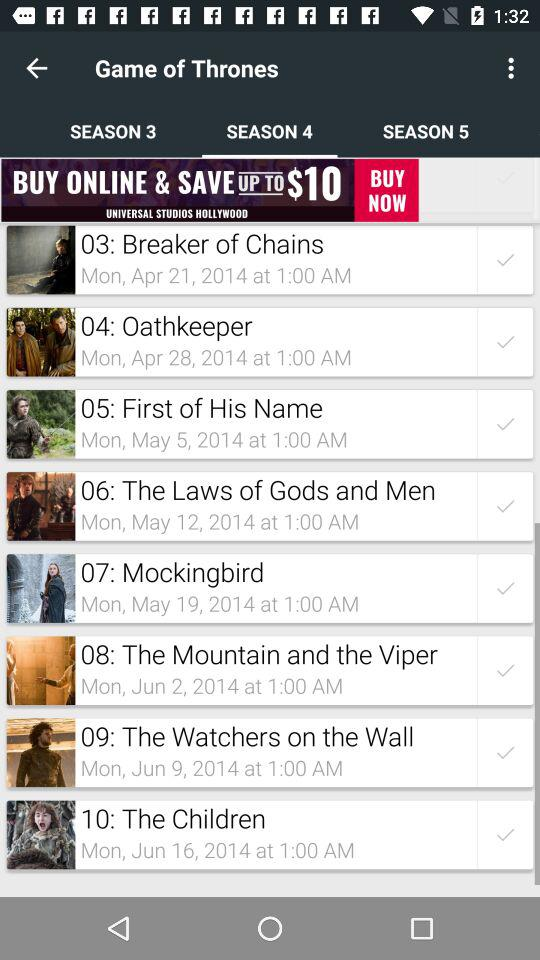What is the date and time for the third episode, "Breaker of Chains"? The date and time for the third episode, "Breaker of Chains" are Monday, April 21, 2014 and 1:00 AM, respectively. 